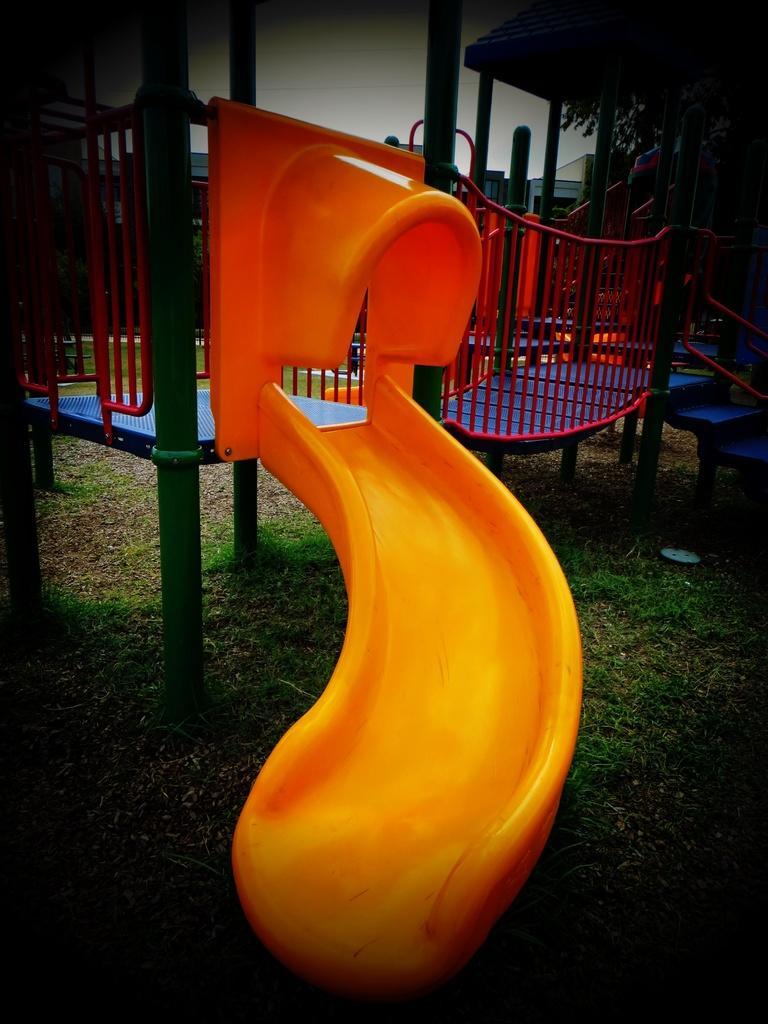Could you give a brief overview of what you see in this image? In this image I can see a garden slide which is yellow in color. In the background I can see the sky and some other objects. 